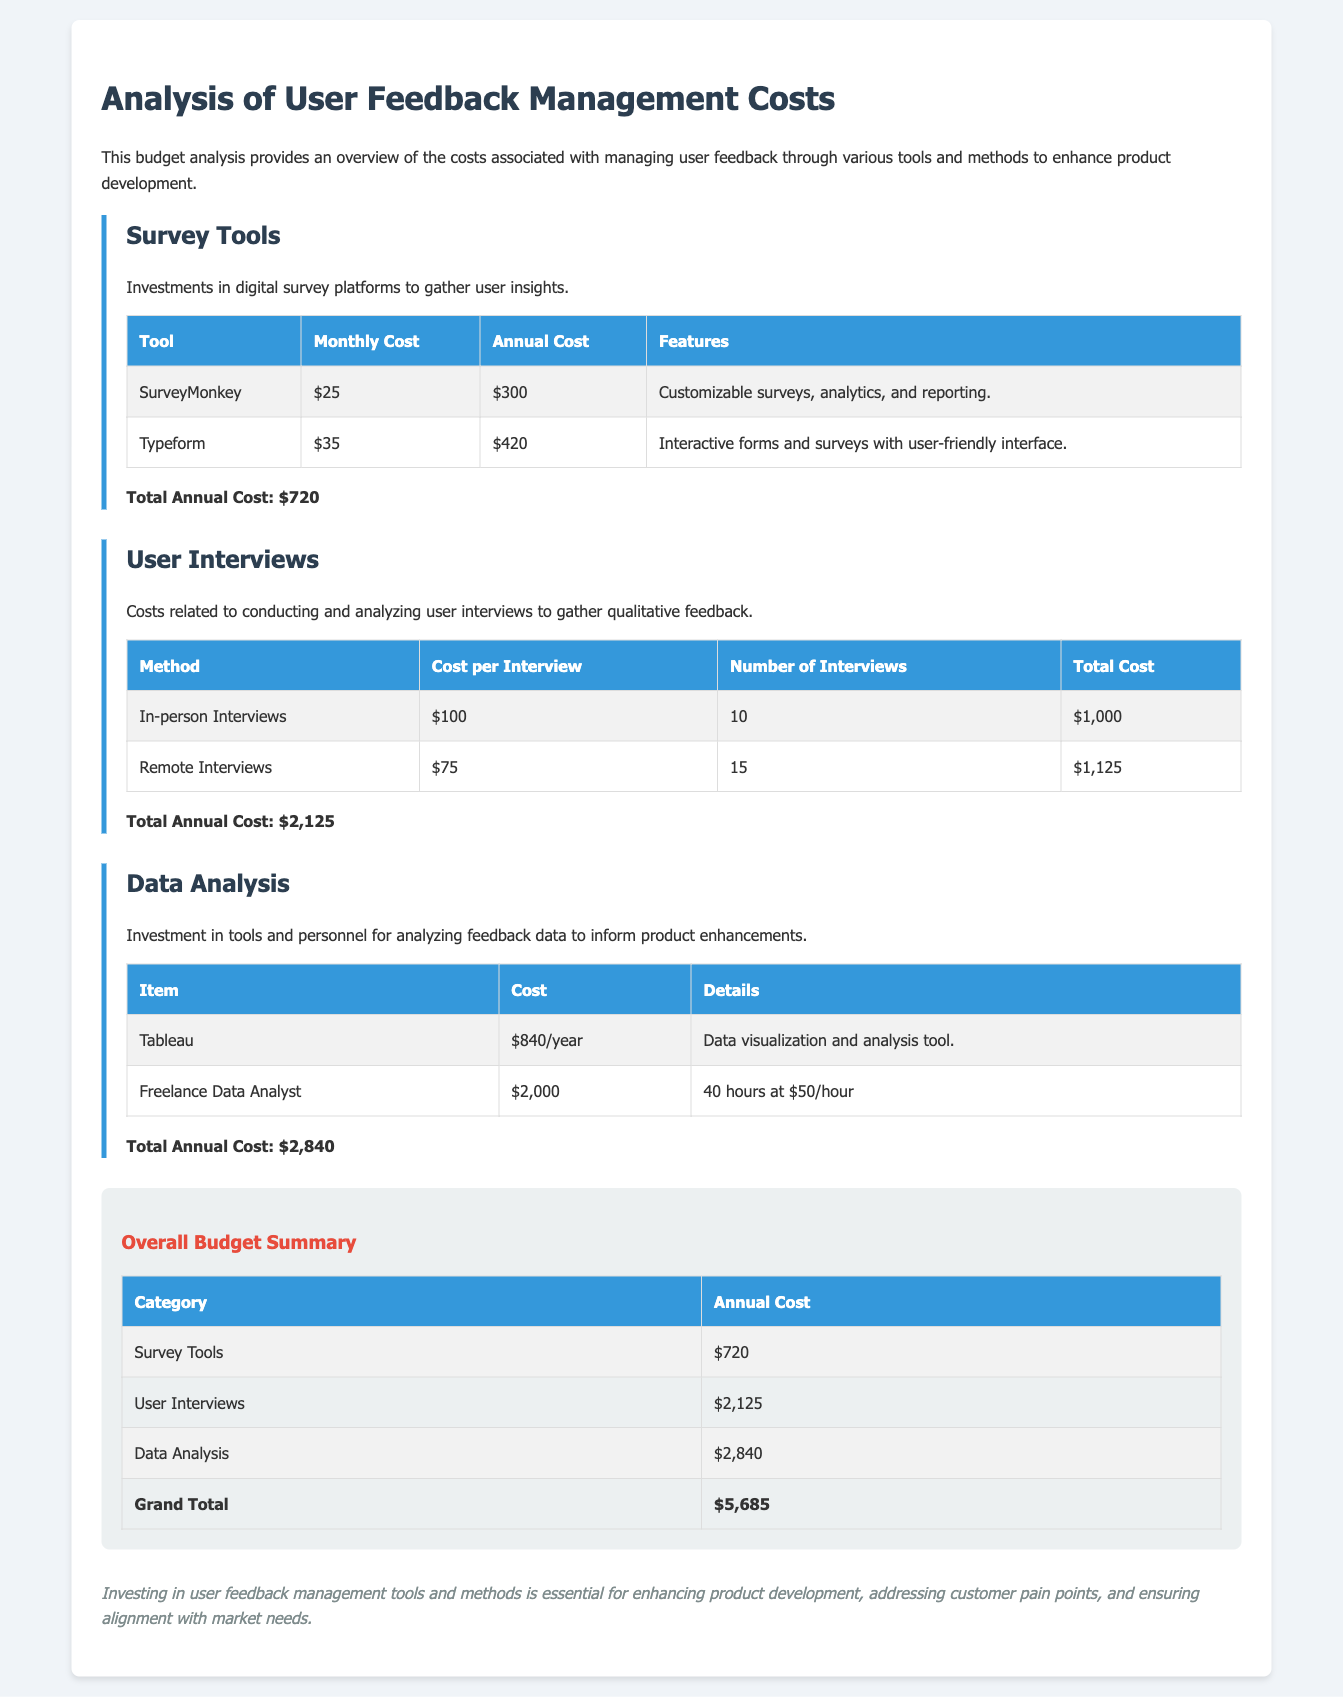what is the total annual cost for survey tools? The total annual cost for survey tools is explicitly mentioned in the document under the Survey Tools section.
Answer: $720 how much does a remote interview cost? The cost per remote interview is specified in the User Interviews section.
Answer: $75 what is the total annual cost for data analysis? The total annual cost for data analysis is provided in the Data Analysis section.
Answer: $2,840 how many in-person interviews are planned? The number of in-person interviews is detailed in the User Interviews section of the document.
Answer: 10 what is the grand total for the overall budget? The grand total is calculated and listed in the Overall Budget Summary at the end of the document.
Answer: $5,685 which survey tool has the highest monthly cost? The monthly costs for the survey tools are compared in the Survey Tools section to find which one is higher.
Answer: Typeform what is the cost of Tableau per year? The annual cost for Tableau is mentioned under the Data Analysis section explicitly.
Answer: $840/year how many total user interviews are planned? The total number of user interviews can be calculated by summing the planned in-person and remote interviews in the User Interviews section.
Answer: 25 what is the total cost for conducting in-person interviews? The total cost for in-person interviews is calculated in the User Interviews section based on the number of interviews and the cost per interview.
Answer: $1,000 